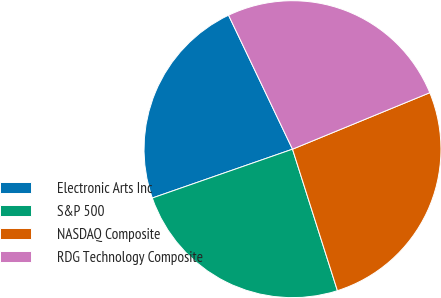Convert chart. <chart><loc_0><loc_0><loc_500><loc_500><pie_chart><fcel>Electronic Arts Inc<fcel>S&P 500<fcel>NASDAQ Composite<fcel>RDG Technology Composite<nl><fcel>23.25%<fcel>24.56%<fcel>26.32%<fcel>25.88%<nl></chart> 